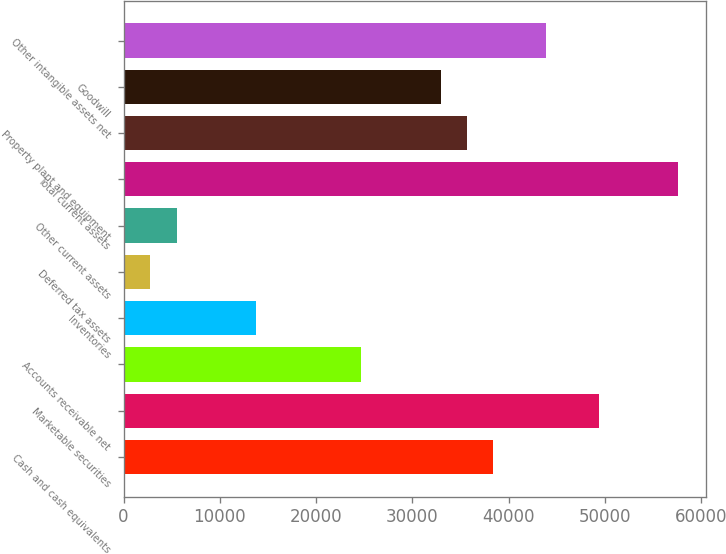Convert chart to OTSL. <chart><loc_0><loc_0><loc_500><loc_500><bar_chart><fcel>Cash and cash equivalents<fcel>Marketable securities<fcel>Accounts receivable net<fcel>Inventories<fcel>Deferred tax assets<fcel>Other current assets<fcel>Total current assets<fcel>Property plant and equipment<fcel>Goodwill<fcel>Other intangible assets net<nl><fcel>38411.4<fcel>49377.8<fcel>24703.4<fcel>13737<fcel>2770.6<fcel>5512.2<fcel>57602.6<fcel>35669.8<fcel>32928.2<fcel>43894.6<nl></chart> 